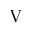<formula> <loc_0><loc_0><loc_500><loc_500>V</formula> 